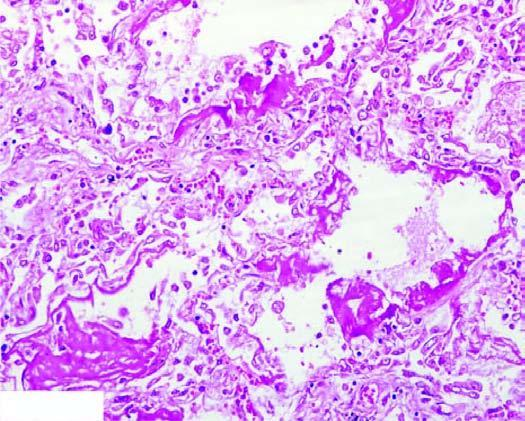re cross section cs alternate areas of collapsed and dilated alveolar spaces, many of which are lined by eosinophilic hyaline membranes?
Answer the question using a single word or phrase. No 